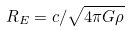Convert formula to latex. <formula><loc_0><loc_0><loc_500><loc_500>R _ { E } = c / \sqrt { 4 \pi G \rho }</formula> 